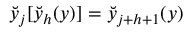Convert formula to latex. <formula><loc_0><loc_0><loc_500><loc_500>\breve { y } _ { j } [ \breve { y } _ { h } ( y ) ] = \breve { y } _ { j + h + 1 } ( y )</formula> 